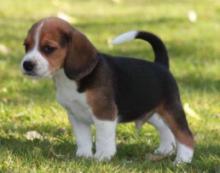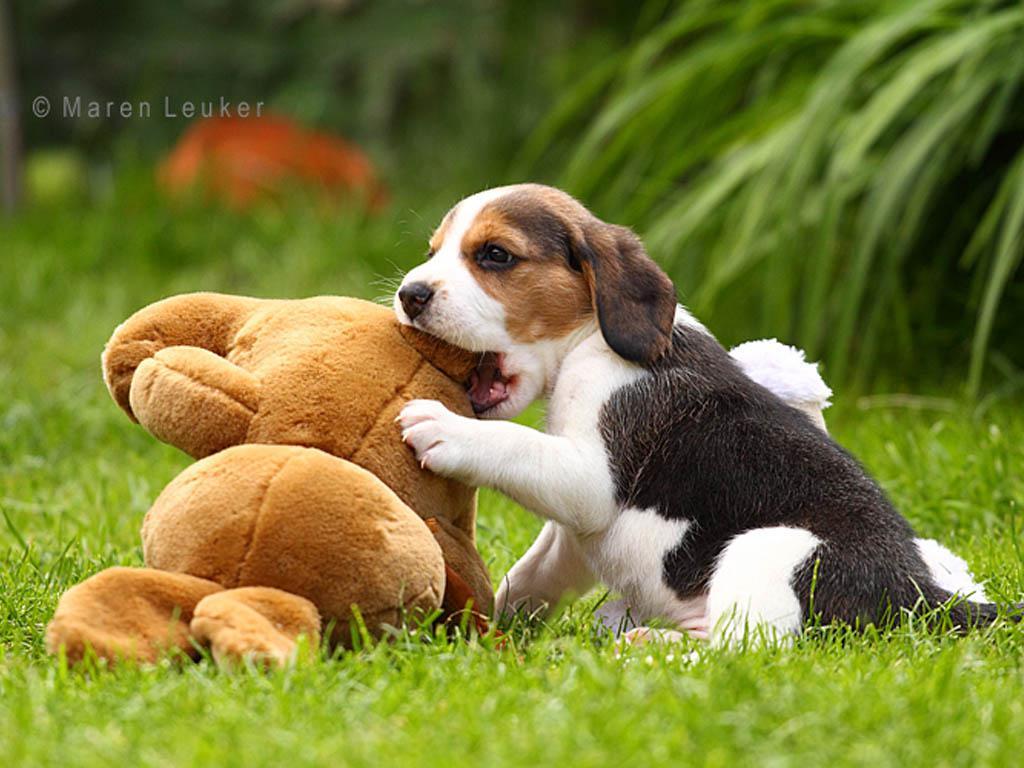The first image is the image on the left, the second image is the image on the right. Examine the images to the left and right. Is the description "There are two dogs" accurate? Answer yes or no. Yes. 